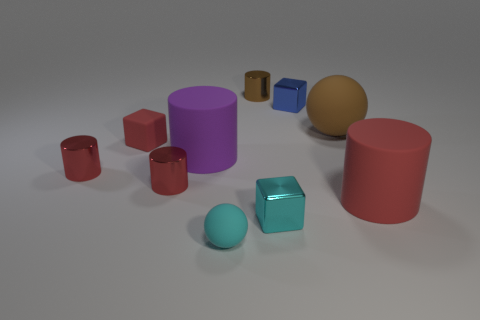Are the tiny blue cube and the cylinder to the right of the tiny blue block made of the same material?
Your answer should be compact. No. What shape is the large thing that is in front of the big matte cylinder left of the small brown metal object?
Ensure brevity in your answer.  Cylinder. The thing that is to the right of the tiny cyan shiny object and to the left of the big brown matte ball has what shape?
Provide a short and direct response. Cube. How many things are small brown rubber cubes or big things behind the purple rubber object?
Make the answer very short. 1. What material is the purple thing that is the same shape as the brown metallic object?
Your response must be concise. Rubber. There is a thing that is both on the right side of the tiny cyan metallic cube and to the left of the brown rubber object; what material is it made of?
Give a very brief answer. Metal. How many other tiny shiny objects are the same shape as the blue shiny thing?
Keep it short and to the point. 1. What is the color of the small shiny cylinder that is on the left side of the tiny matte thing that is to the left of the small cyan rubber sphere?
Ensure brevity in your answer.  Red. Is the number of red rubber blocks that are to the left of the brown shiny cylinder the same as the number of red metal objects?
Keep it short and to the point. No. Is there a red block that has the same size as the cyan shiny object?
Give a very brief answer. Yes. 